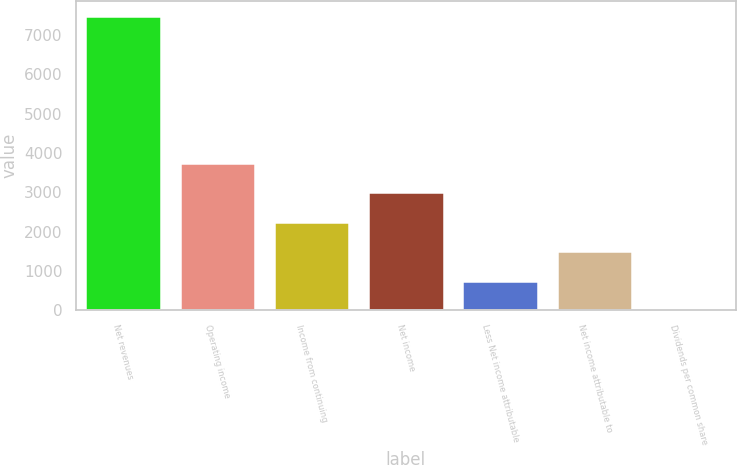<chart> <loc_0><loc_0><loc_500><loc_500><bar_chart><fcel>Net revenues<fcel>Operating income<fcel>Income from continuing<fcel>Net income<fcel>Less Net income attributable<fcel>Net income attributable to<fcel>Dividends per common share<nl><fcel>7493<fcel>3747.27<fcel>2248.97<fcel>2998.12<fcel>750.67<fcel>1499.82<fcel>1.52<nl></chart> 